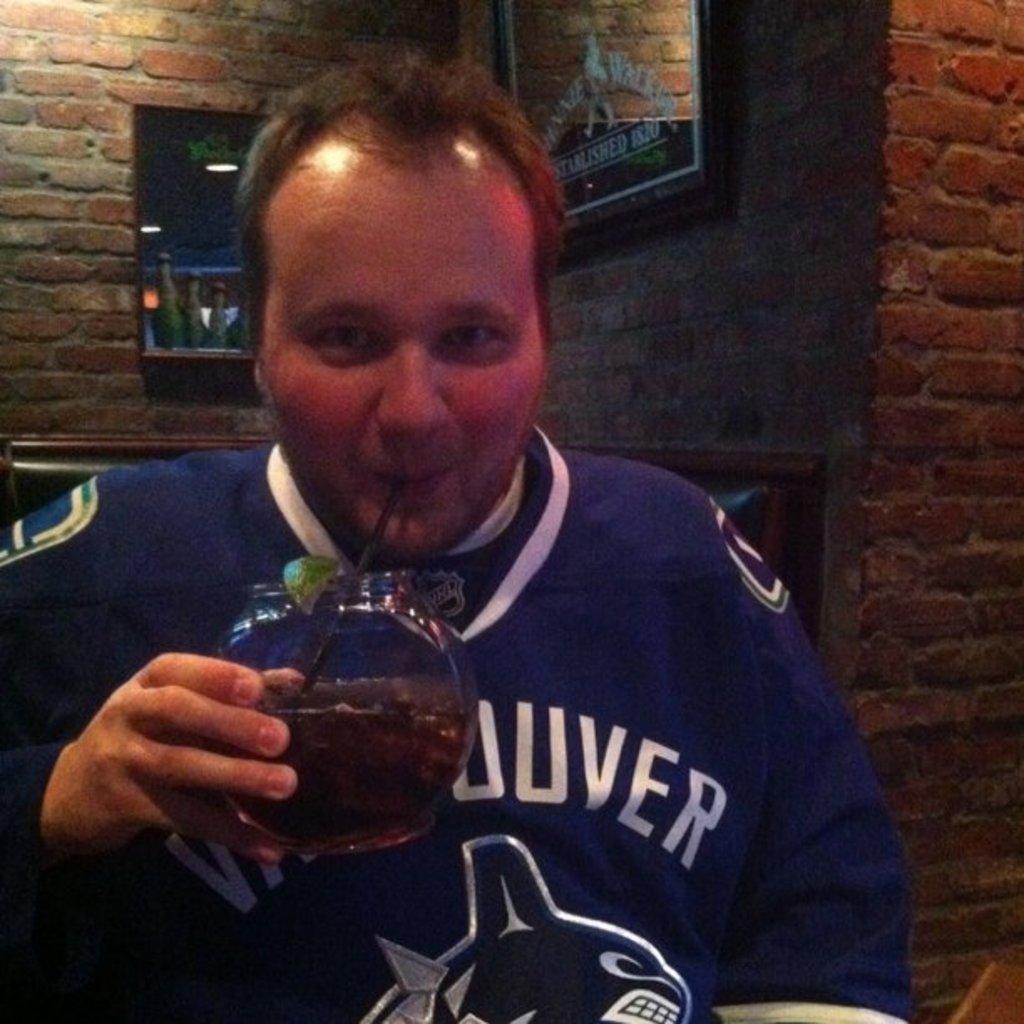Can you describe this image briefly? In this picture we can see a man, he is holding a glass and he is drinking with the help of straw, behind him we can see few lights and a frame on the wall. 